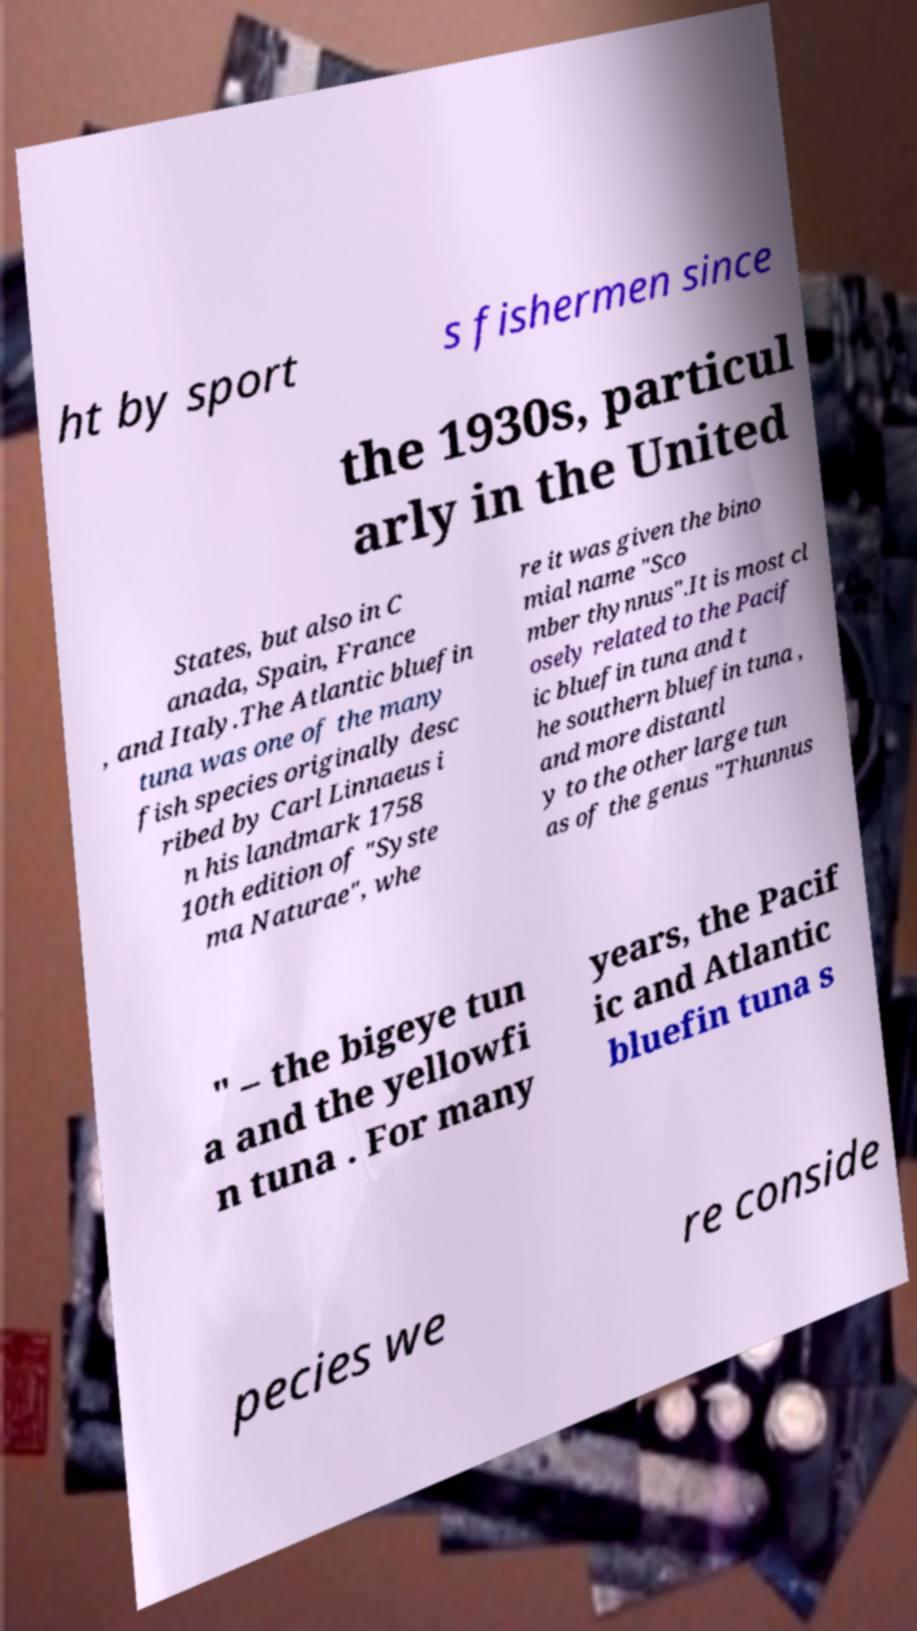Can you accurately transcribe the text from the provided image for me? ht by sport s fishermen since the 1930s, particul arly in the United States, but also in C anada, Spain, France , and Italy.The Atlantic bluefin tuna was one of the many fish species originally desc ribed by Carl Linnaeus i n his landmark 1758 10th edition of "Syste ma Naturae", whe re it was given the bino mial name "Sco mber thynnus".It is most cl osely related to the Pacif ic bluefin tuna and t he southern bluefin tuna , and more distantl y to the other large tun as of the genus "Thunnus " – the bigeye tun a and the yellowfi n tuna . For many years, the Pacif ic and Atlantic bluefin tuna s pecies we re conside 